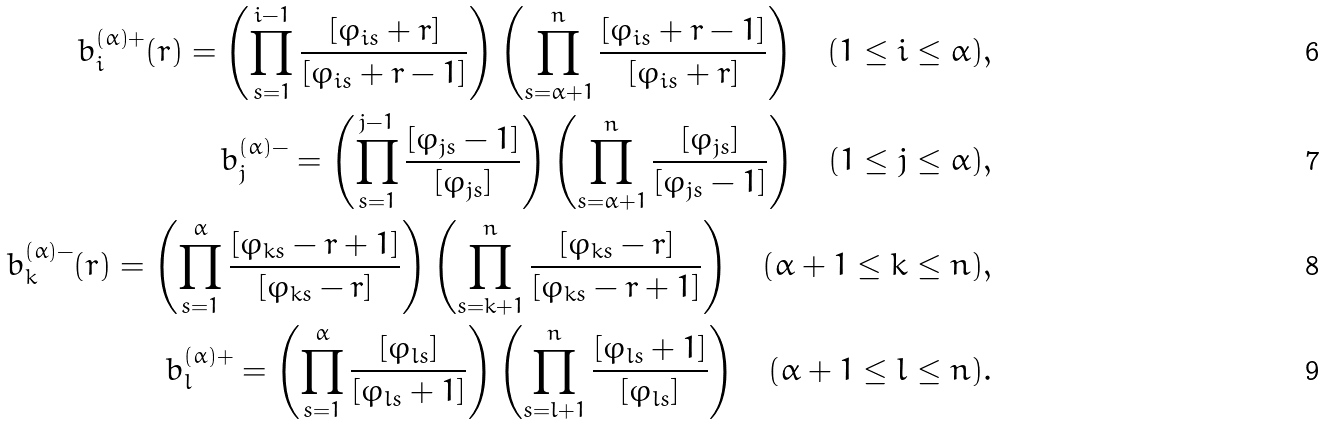Convert formula to latex. <formula><loc_0><loc_0><loc_500><loc_500>b _ { i } ^ { ( \alpha ) + } ( r ) = \left ( \prod _ { s = 1 } ^ { i - 1 } \frac { [ \varphi _ { i s } + r ] } { [ \varphi _ { i s } + r - 1 ] } \right ) \left ( \prod _ { s = \alpha + 1 } ^ { n } \frac { [ \varphi _ { i s } + r - 1 ] } { [ \varphi _ { i s } + r ] } \right ) \quad ( 1 \leq i \leq \alpha ) , \\ b _ { j } ^ { ( \alpha ) - } = \left ( \prod _ { s = 1 } ^ { j - 1 } \frac { [ \varphi _ { j s } - 1 ] } { [ \varphi _ { j s } ] } \right ) \left ( \prod _ { s = \alpha + 1 } ^ { n } \frac { [ \varphi _ { j s } ] } { [ \varphi _ { j s } - 1 ] } \right ) \quad ( 1 \leq j \leq \alpha ) , \\ b _ { k } ^ { ( \alpha ) - } ( r ) = \left ( \prod _ { s = 1 } ^ { \alpha } \frac { [ \varphi _ { k s } - r + 1 ] } { [ \varphi _ { k s } - r ] } \right ) \left ( \prod _ { s = k + 1 } ^ { n } \frac { [ \varphi _ { k s } - r ] } { [ \varphi _ { k s } - r + 1 ] } \right ) \quad ( \alpha + 1 \leq k \leq n ) , \\ b _ { l } ^ { ( \alpha ) + } = \left ( \prod _ { s = 1 } ^ { \alpha } \frac { [ \varphi _ { l s } ] } { [ \varphi _ { l s } + 1 ] } \right ) \left ( \prod _ { s = l + 1 } ^ { n } \frac { [ \varphi _ { l s } + 1 ] } { [ \varphi _ { l s } ] } \right ) \quad ( \alpha + 1 \leq l \leq n ) .</formula> 